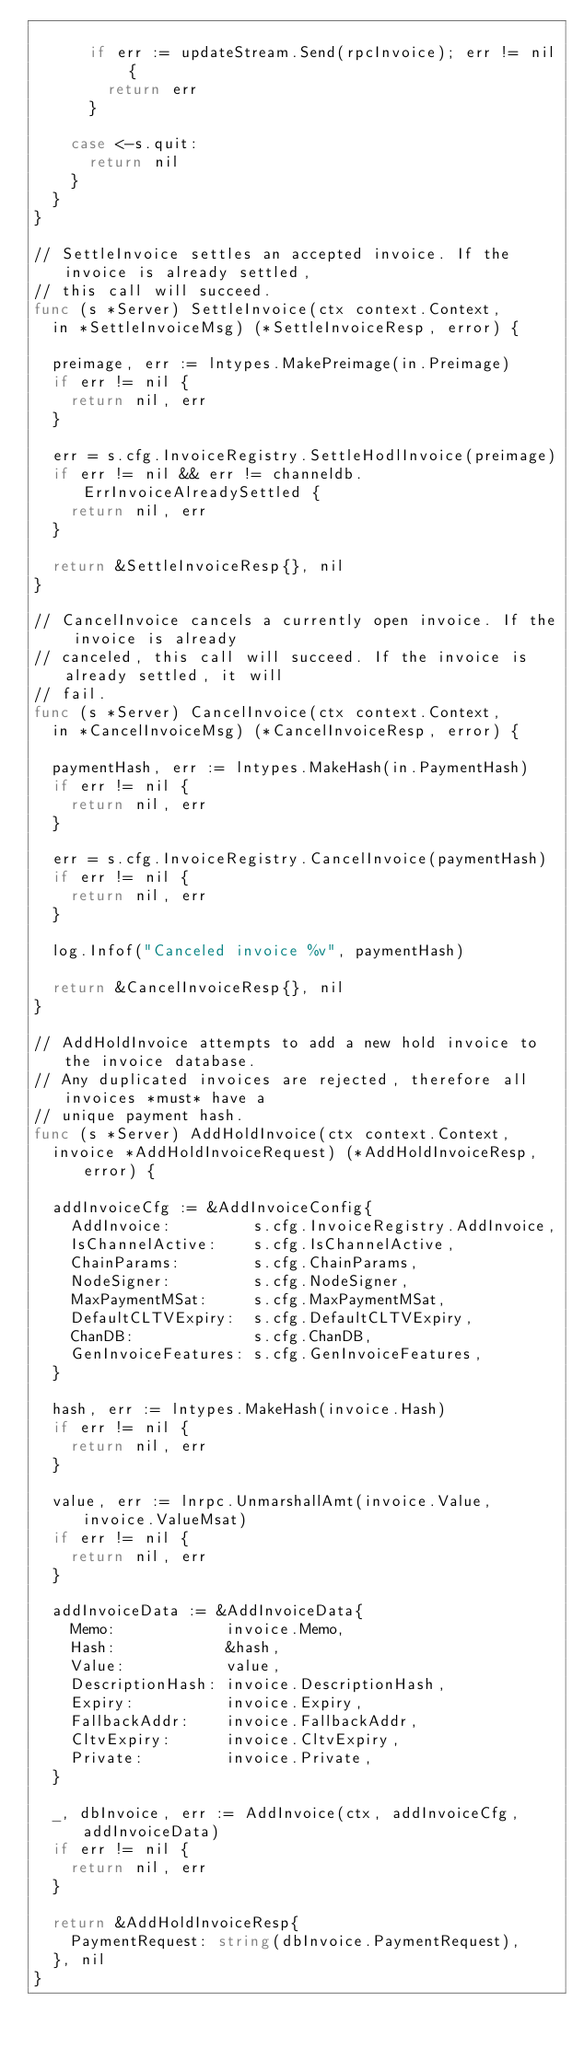<code> <loc_0><loc_0><loc_500><loc_500><_Go_>
			if err := updateStream.Send(rpcInvoice); err != nil {
				return err
			}

		case <-s.quit:
			return nil
		}
	}
}

// SettleInvoice settles an accepted invoice. If the invoice is already settled,
// this call will succeed.
func (s *Server) SettleInvoice(ctx context.Context,
	in *SettleInvoiceMsg) (*SettleInvoiceResp, error) {

	preimage, err := lntypes.MakePreimage(in.Preimage)
	if err != nil {
		return nil, err
	}

	err = s.cfg.InvoiceRegistry.SettleHodlInvoice(preimage)
	if err != nil && err != channeldb.ErrInvoiceAlreadySettled {
		return nil, err
	}

	return &SettleInvoiceResp{}, nil
}

// CancelInvoice cancels a currently open invoice. If the invoice is already
// canceled, this call will succeed. If the invoice is already settled, it will
// fail.
func (s *Server) CancelInvoice(ctx context.Context,
	in *CancelInvoiceMsg) (*CancelInvoiceResp, error) {

	paymentHash, err := lntypes.MakeHash(in.PaymentHash)
	if err != nil {
		return nil, err
	}

	err = s.cfg.InvoiceRegistry.CancelInvoice(paymentHash)
	if err != nil {
		return nil, err
	}

	log.Infof("Canceled invoice %v", paymentHash)

	return &CancelInvoiceResp{}, nil
}

// AddHoldInvoice attempts to add a new hold invoice to the invoice database.
// Any duplicated invoices are rejected, therefore all invoices *must* have a
// unique payment hash.
func (s *Server) AddHoldInvoice(ctx context.Context,
	invoice *AddHoldInvoiceRequest) (*AddHoldInvoiceResp, error) {

	addInvoiceCfg := &AddInvoiceConfig{
		AddInvoice:         s.cfg.InvoiceRegistry.AddInvoice,
		IsChannelActive:    s.cfg.IsChannelActive,
		ChainParams:        s.cfg.ChainParams,
		NodeSigner:         s.cfg.NodeSigner,
		MaxPaymentMSat:     s.cfg.MaxPaymentMSat,
		DefaultCLTVExpiry:  s.cfg.DefaultCLTVExpiry,
		ChanDB:             s.cfg.ChanDB,
		GenInvoiceFeatures: s.cfg.GenInvoiceFeatures,
	}

	hash, err := lntypes.MakeHash(invoice.Hash)
	if err != nil {
		return nil, err
	}

	value, err := lnrpc.UnmarshallAmt(invoice.Value, invoice.ValueMsat)
	if err != nil {
		return nil, err
	}

	addInvoiceData := &AddInvoiceData{
		Memo:            invoice.Memo,
		Hash:            &hash,
		Value:           value,
		DescriptionHash: invoice.DescriptionHash,
		Expiry:          invoice.Expiry,
		FallbackAddr:    invoice.FallbackAddr,
		CltvExpiry:      invoice.CltvExpiry,
		Private:         invoice.Private,
	}

	_, dbInvoice, err := AddInvoice(ctx, addInvoiceCfg, addInvoiceData)
	if err != nil {
		return nil, err
	}

	return &AddHoldInvoiceResp{
		PaymentRequest: string(dbInvoice.PaymentRequest),
	}, nil
}
</code> 